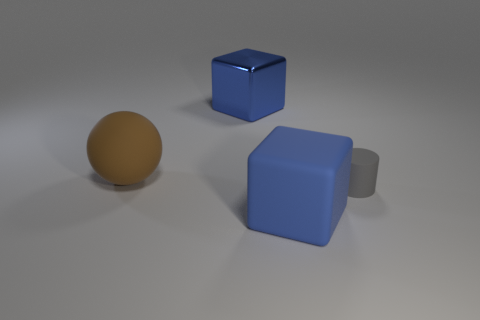What is the color of the small thing?
Make the answer very short. Gray. Is there a gray metallic cylinder?
Give a very brief answer. No. Are there any large blue metal cubes to the left of the rubber sphere?
Your answer should be compact. No. What is the material of the other big blue object that is the same shape as the metallic thing?
Your answer should be very brief. Rubber. Is there anything else that has the same material as the large sphere?
Your answer should be compact. Yes. How many other things are the same shape as the brown object?
Your answer should be very brief. 0. How many big blue blocks are in front of the blue cube that is to the left of the blue matte object that is on the left side of the cylinder?
Offer a terse response. 1. How many blue matte things have the same shape as the metallic thing?
Provide a succinct answer. 1. There is a big cube behind the cylinder; is its color the same as the small cylinder?
Your response must be concise. No. The blue thing behind the big matte object that is on the left side of the big blue cube that is in front of the large brown sphere is what shape?
Ensure brevity in your answer.  Cube. 